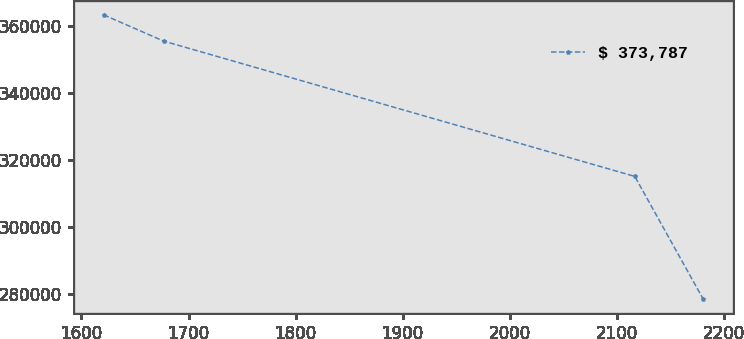Convert chart to OTSL. <chart><loc_0><loc_0><loc_500><loc_500><line_chart><ecel><fcel>$ 373,787<nl><fcel>1620.7<fcel>363396<nl><fcel>1676.7<fcel>355559<nl><fcel>2116.9<fcel>315110<nl><fcel>2180.73<fcel>278486<nl></chart> 